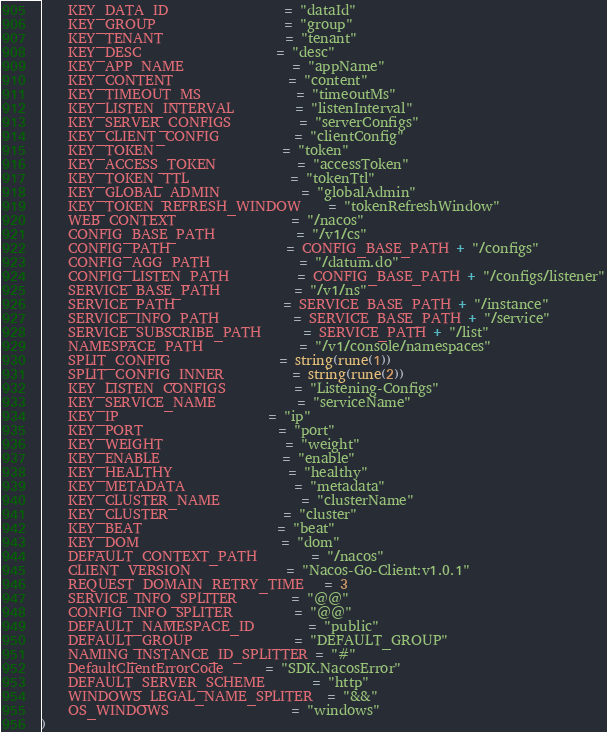<code> <loc_0><loc_0><loc_500><loc_500><_Go_>	KEY_DATA_ID                 = "dataId"
	KEY_GROUP                   = "group"
	KEY_TENANT                  = "tenant"
	KEY_DESC                    = "desc"
	KEY_APP_NAME                = "appName"
	KEY_CONTENT                 = "content"
	KEY_TIMEOUT_MS              = "timeoutMs"
	KEY_LISTEN_INTERVAL         = "listenInterval"
	KEY_SERVER_CONFIGS          = "serverConfigs"
	KEY_CLIENT_CONFIG           = "clientConfig"
	KEY_TOKEN                   = "token"
	KEY_ACCESS_TOKEN            = "accessToken"
	KEY_TOKEN_TTL               = "tokenTtl"
	KEY_GLOBAL_ADMIN            = "globalAdmin"
	KEY_TOKEN_REFRESH_WINDOW    = "tokenRefreshWindow"
	WEB_CONTEXT                 = "/nacos"
	CONFIG_BASE_PATH            = "/v1/cs"
	CONFIG_PATH                 = CONFIG_BASE_PATH + "/configs"
	CONFIG_AGG_PATH             = "/datum.do"
	CONFIG_LISTEN_PATH          = CONFIG_BASE_PATH + "/configs/listener"
	SERVICE_BASE_PATH           = "/v1/ns"
	SERVICE_PATH                = SERVICE_BASE_PATH + "/instance"
	SERVICE_INFO_PATH           = SERVICE_BASE_PATH + "/service"
	SERVICE_SUBSCRIBE_PATH      = SERVICE_PATH + "/list"
	NAMESPACE_PATH              = "/v1/console/namespaces"
	SPLIT_CONFIG                = string(rune(1))
	SPLIT_CONFIG_INNER          = string(rune(2))
	KEY_LISTEN_CONFIGS          = "Listening-Configs"
	KEY_SERVICE_NAME            = "serviceName"
	KEY_IP                      = "ip"
	KEY_PORT                    = "port"
	KEY_WEIGHT                  = "weight"
	KEY_ENABLE                  = "enable"
	KEY_HEALTHY                 = "healthy"
	KEY_METADATA                = "metadata"
	KEY_CLUSTER_NAME            = "clusterName"
	KEY_CLUSTER                 = "cluster"
	KEY_BEAT                    = "beat"
	KEY_DOM                     = "dom"
	DEFAULT_CONTEXT_PATH        = "/nacos"
	CLIENT_VERSION              = "Nacos-Go-Client:v1.0.1"
	REQUEST_DOMAIN_RETRY_TIME   = 3
	SERVICE_INFO_SPLITER        = "@@"
	CONFIG_INFO_SPLITER         = "@@"
	DEFAULT_NAMESPACE_ID        = "public"
	DEFAULT_GROUP               = "DEFAULT_GROUP"
	NAMING_INSTANCE_ID_SPLITTER = "#"
	DefaultClientErrorCode      = "SDK.NacosError"
	DEFAULT_SERVER_SCHEME       = "http"
	WINDOWS_LEGAL_NAME_SPLITER  = "&&"
	OS_WINDOWS                  = "windows"
)
</code> 